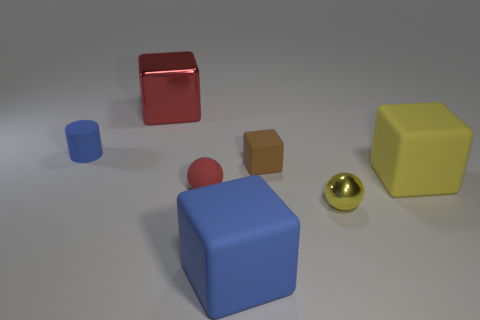Subtract all purple blocks. Subtract all gray cylinders. How many blocks are left? 4 Add 1 brown things. How many objects exist? 8 Subtract all spheres. How many objects are left? 5 Subtract all tiny shiny spheres. Subtract all blue rubber cylinders. How many objects are left? 5 Add 3 rubber cylinders. How many rubber cylinders are left? 4 Add 6 red cylinders. How many red cylinders exist? 6 Subtract 0 green cylinders. How many objects are left? 7 